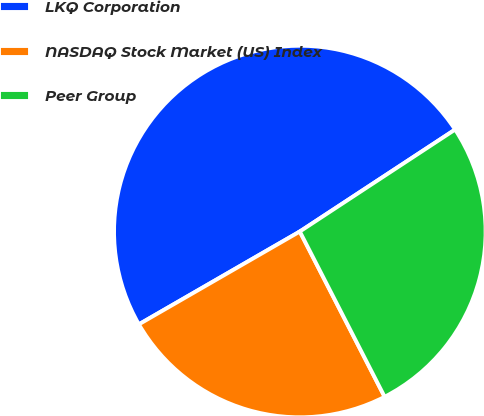Convert chart to OTSL. <chart><loc_0><loc_0><loc_500><loc_500><pie_chart><fcel>LKQ Corporation<fcel>NASDAQ Stock Market (US) Index<fcel>Peer Group<nl><fcel>49.08%<fcel>24.22%<fcel>26.7%<nl></chart> 